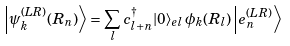<formula> <loc_0><loc_0><loc_500><loc_500>\left | \psi ^ { ( L R ) } _ { k } ( R _ { n } ) \right \rangle = \sum _ { l } c ^ { \dagger } _ { l + n } | 0 \rangle _ { e l } \, \phi _ { k } ( R _ { l } ) \left | e ^ { ( L R ) } _ { n } \right \rangle</formula> 